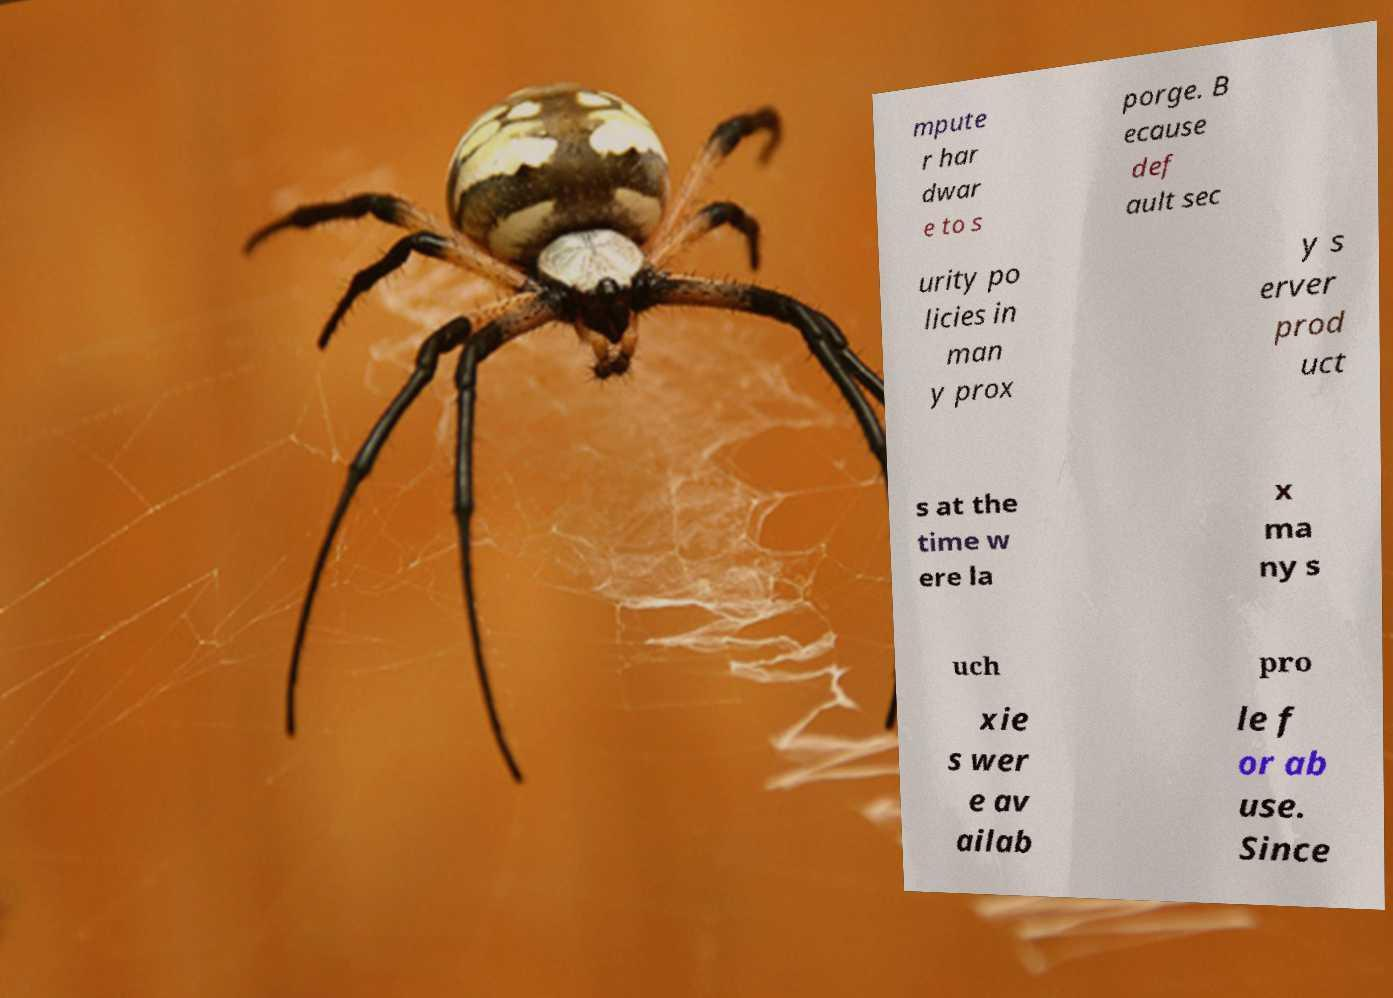Could you extract and type out the text from this image? mpute r har dwar e to s porge. B ecause def ault sec urity po licies in man y prox y s erver prod uct s at the time w ere la x ma ny s uch pro xie s wer e av ailab le f or ab use. Since 